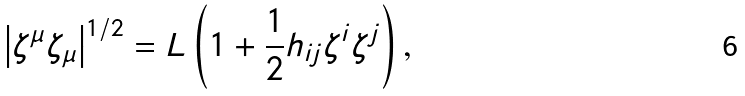<formula> <loc_0><loc_0><loc_500><loc_500>\left | \zeta ^ { \mu } \zeta _ { \mu } \right | ^ { 1 / 2 } = L \left ( 1 + \frac { 1 } { 2 } h _ { i j } \zeta ^ { i } \zeta ^ { j } \right ) ,</formula> 